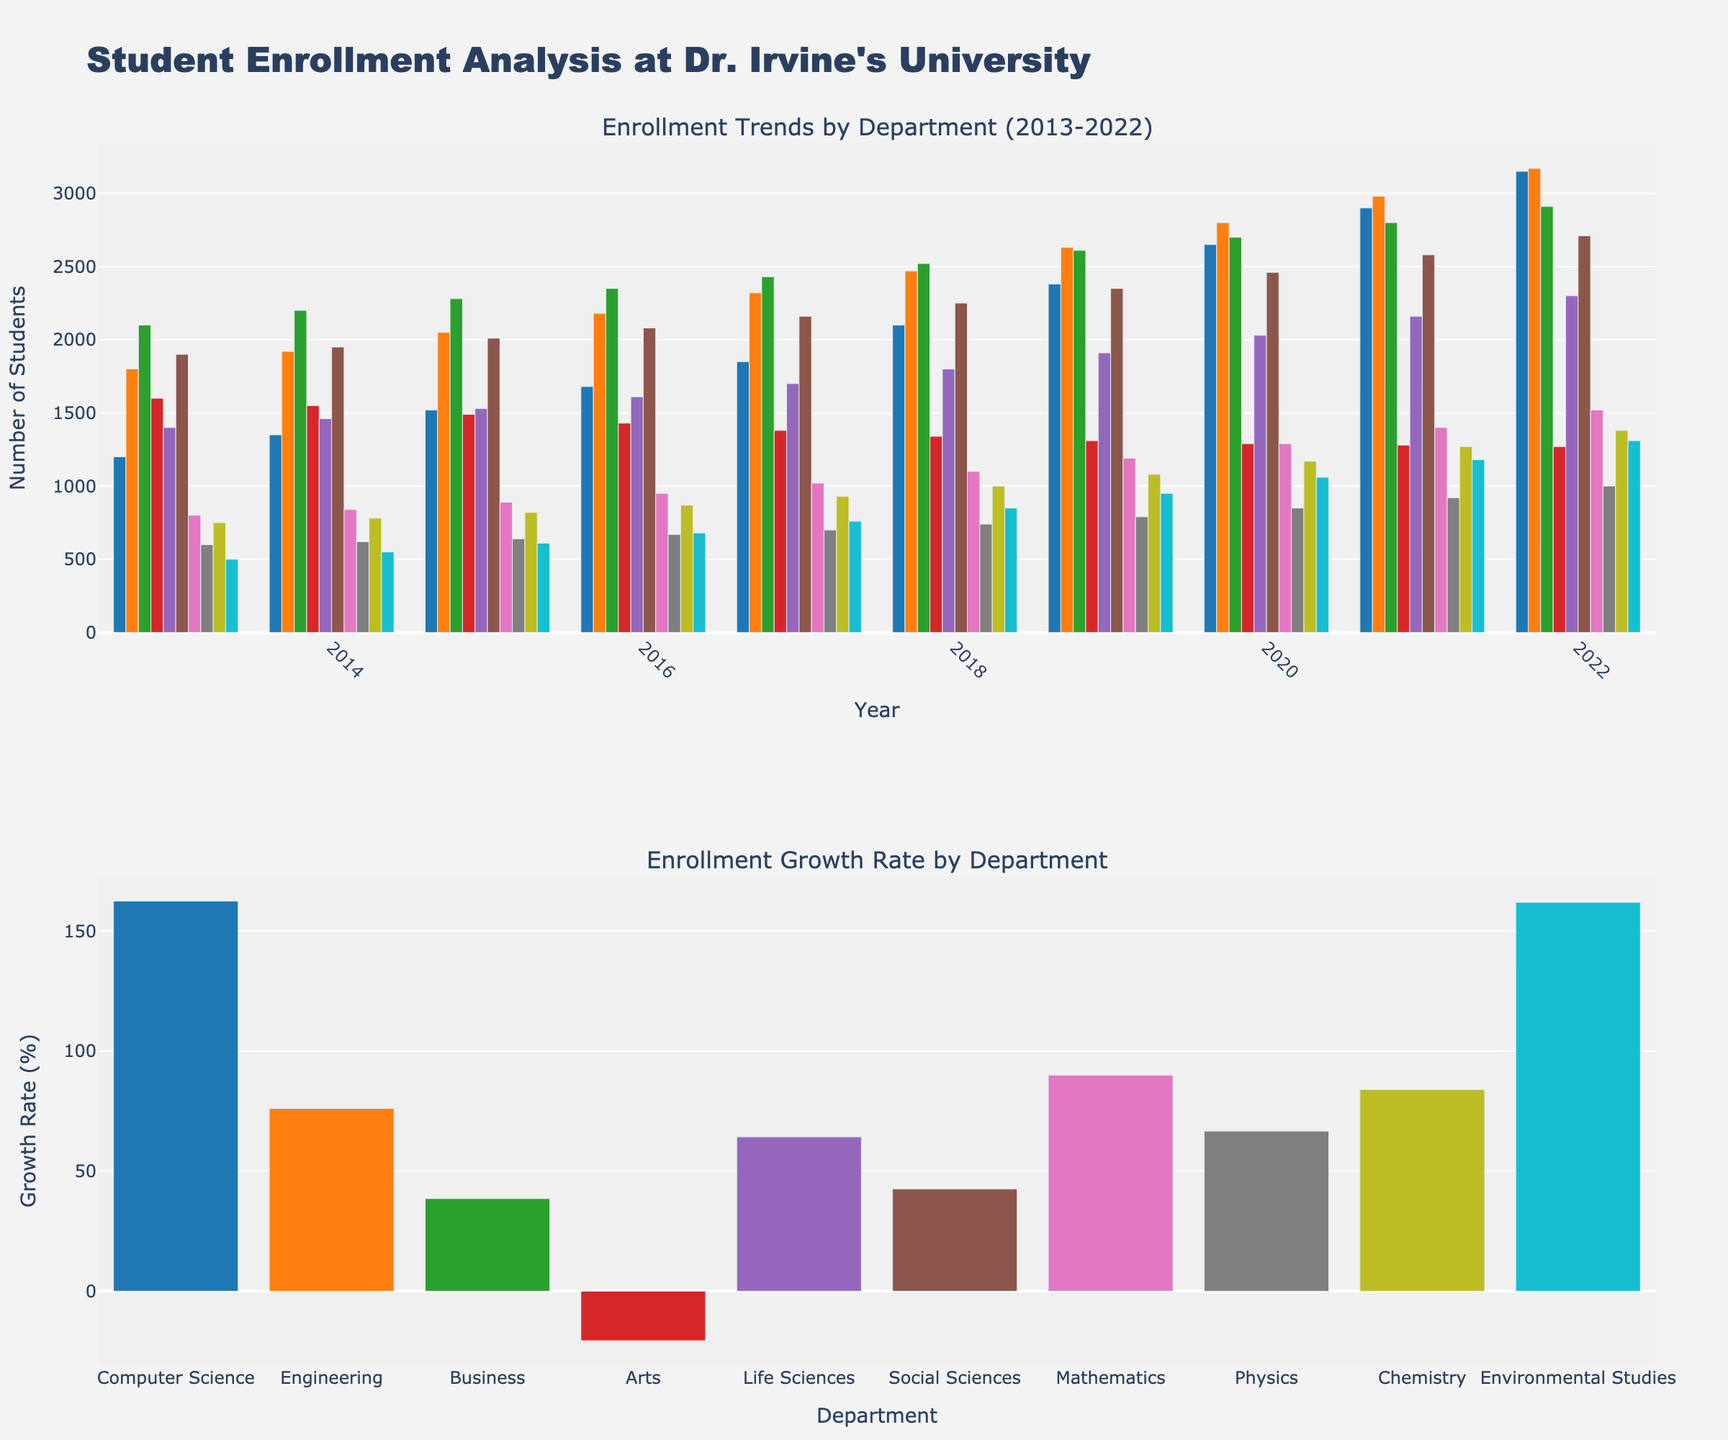What's the department with the highest enrollment in 2022? In the subplot of "Enrollment Trends by Department (2013-2022)", the tallest bar in 2022 belongs to the Computer Science department.
Answer: Computer Science Which department showed the largest growth rate over the decade? In the subplot "Enrollment Growth Rate by Department," the bar representing the Computer Science department is the tallest, indicating the highest growth rate.
Answer: Computer Science How did the enrollment figures for the Arts department change from 2013 to 2022? By looking at the bars for the Arts department in the "Enrollment Trends by Department (2013-2022)" subplot, the height decreases from 1600 in 2013 to 1270 in 2022, indicating a decline.
Answer: Declined Compare the enrollment figures of Computer Science with Mathematics in 2022. In 2022, the Computer Science bar is much taller than the Mathematics bar, indicating significantly higher enrollment for Computer Science.
Answer: Computer Science > Mathematics Which department had the least growth, and what was its growth rate? From the "Enrollment Growth Rate by Department" subplot, the shortest bar represents the Arts department, indicating the lowest growth rate, which is negative.
Answer: Arts, negative growth rate What's the average enrollment increase for Social Sciences from 2013 to 2022? To find the average increase: 
1. Subtract the 2013 value from the 2022 value (2710 - 1900 = 810).
2. Divide by the number of years (810/9 = 90).
So, the average annual increase is 90 students.
Answer: 90 students Which three departments had the highest student enrollment in 2013? By looking at the bars representing 2013 in the "Enrollment Trends by Department (2013-2022)" subplot, the top three departments with the tallest bars are Business, Engineering, and Social Sciences.
Answer: Business, Engineering, Social Sciences Compare the trend of Life Sciences with Environmental Studies. Both departments showed an upward trend, but the Life Sciences department has a more steady increase, whereas Environmental Studies had a steeper increase in the later years.
Answer: Steady vs. Steeper later What is the enrollment figure difference between Engineering and Business in 2017? The height of the bars in 2017 indicates:
1. Engineering: 2320
2. Business: 2430
The difference is 2430 - 2320 = 110.
Answer: 110 What percentage increase in enrollment did Computer Science experience from 2013 to 2022? To find the percentage increase:
1. Calculate the difference (3150 - 1200 = 1950).
2. Divide by the initial value (1950 / 1200 ≈ 1.625).
3. Multiply by 100 (1.625 * 100 ≈ 162.5%).
So, the percentage increase is approximately 162.5%.
Answer: 162.5% 